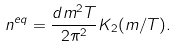Convert formula to latex. <formula><loc_0><loc_0><loc_500><loc_500>n ^ { e q } = \frac { d m ^ { 2 } T } { 2 \pi ^ { 2 } } K _ { 2 } ( m / T ) .</formula> 